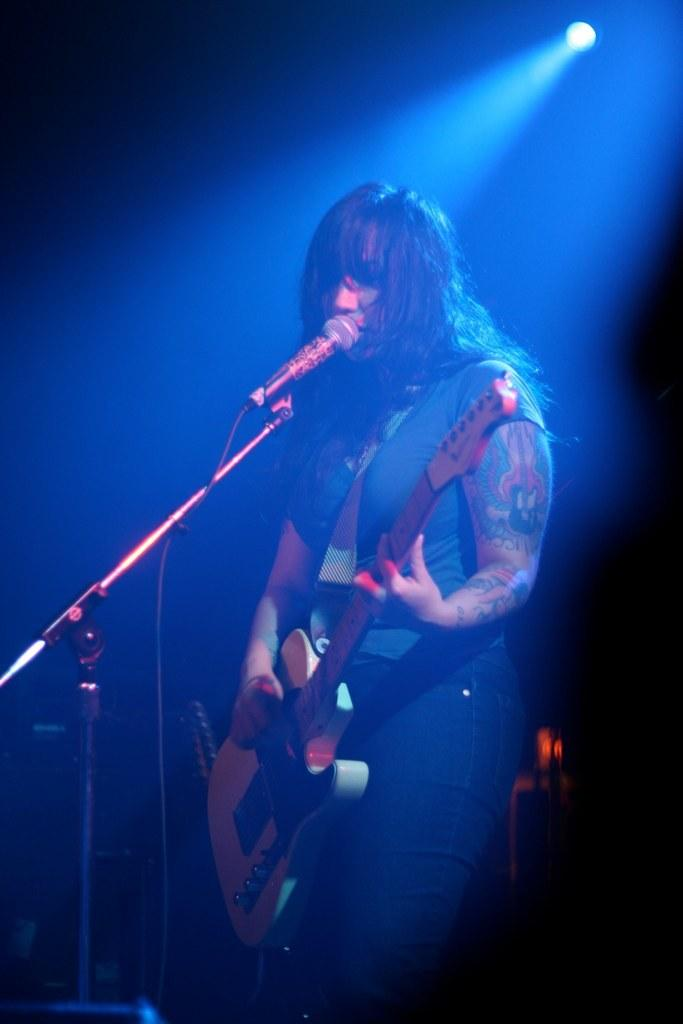What is the main subject of the image? There is a person in the image. What is the person doing in the image? The person is standing in the image. What object is the person holding in her hand? The person is holding a guitar in her hand. What equipment is set up in front of the person? There is a microphone with a stand in front of the person. Can you see a frog playing the guitar in the image? No, there is no frog present in the image, and the person is the one holding the guitar. What type of need is the person using to sew in the image? There is no sewing or needles present in the image; the person is holding a guitar. 